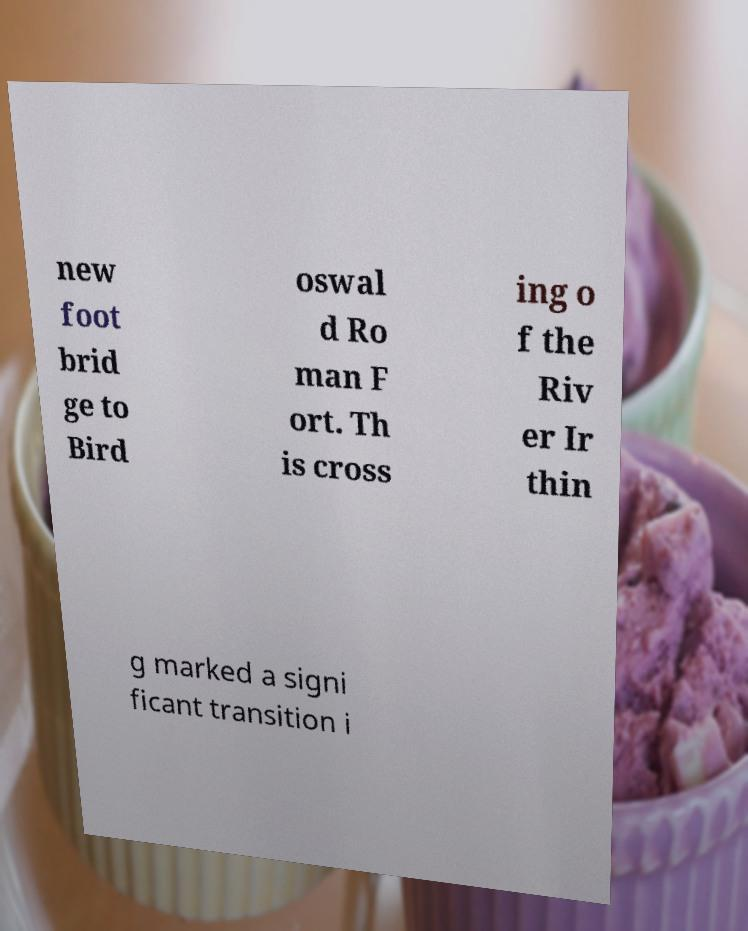Can you accurately transcribe the text from the provided image for me? new foot brid ge to Bird oswal d Ro man F ort. Th is cross ing o f the Riv er Ir thin g marked a signi ficant transition i 